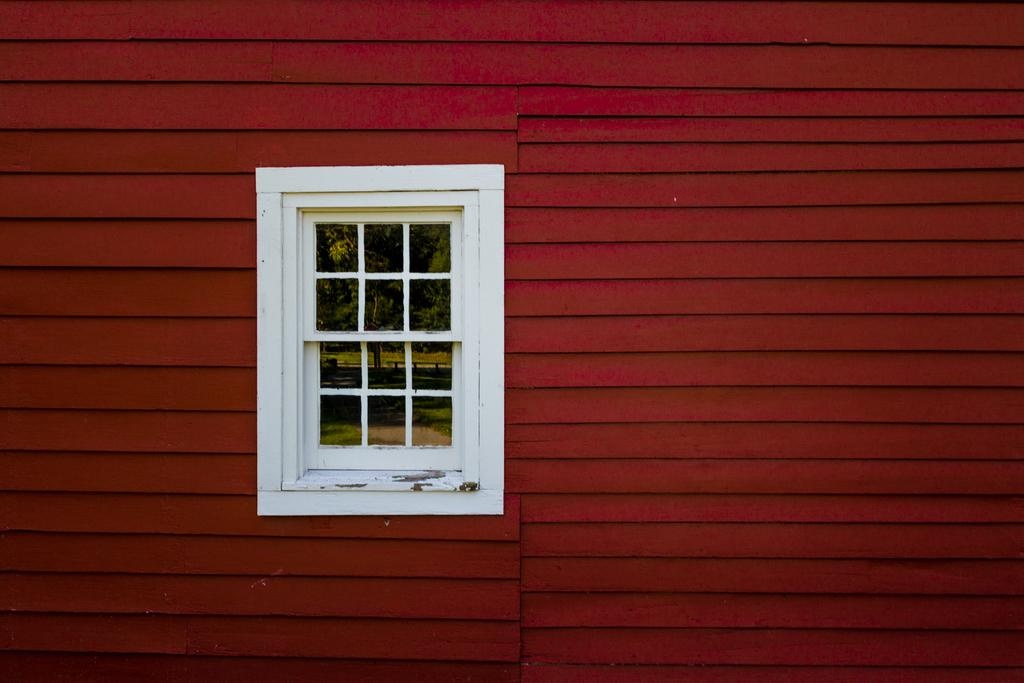What color is the wall in the image? The wall in the image is red. What color is the window in the image? The window in the image is white. What can be seen through the window in the image? Trees are visible through the window in the image. Are there any kites flying in the image? There are no kites visible in the image. What book is being read in the image? There is no reading or book present in the image. 